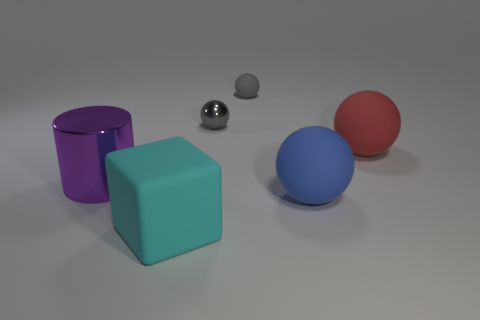Subtract 2 balls. How many balls are left? 2 Add 2 small gray metallic balls. How many objects exist? 8 Subtract all spheres. How many objects are left? 2 Add 1 large rubber objects. How many large rubber objects are left? 4 Add 1 large metal cylinders. How many large metal cylinders exist? 2 Subtract 0 gray cubes. How many objects are left? 6 Subtract all purple metallic cylinders. Subtract all shiny cylinders. How many objects are left? 4 